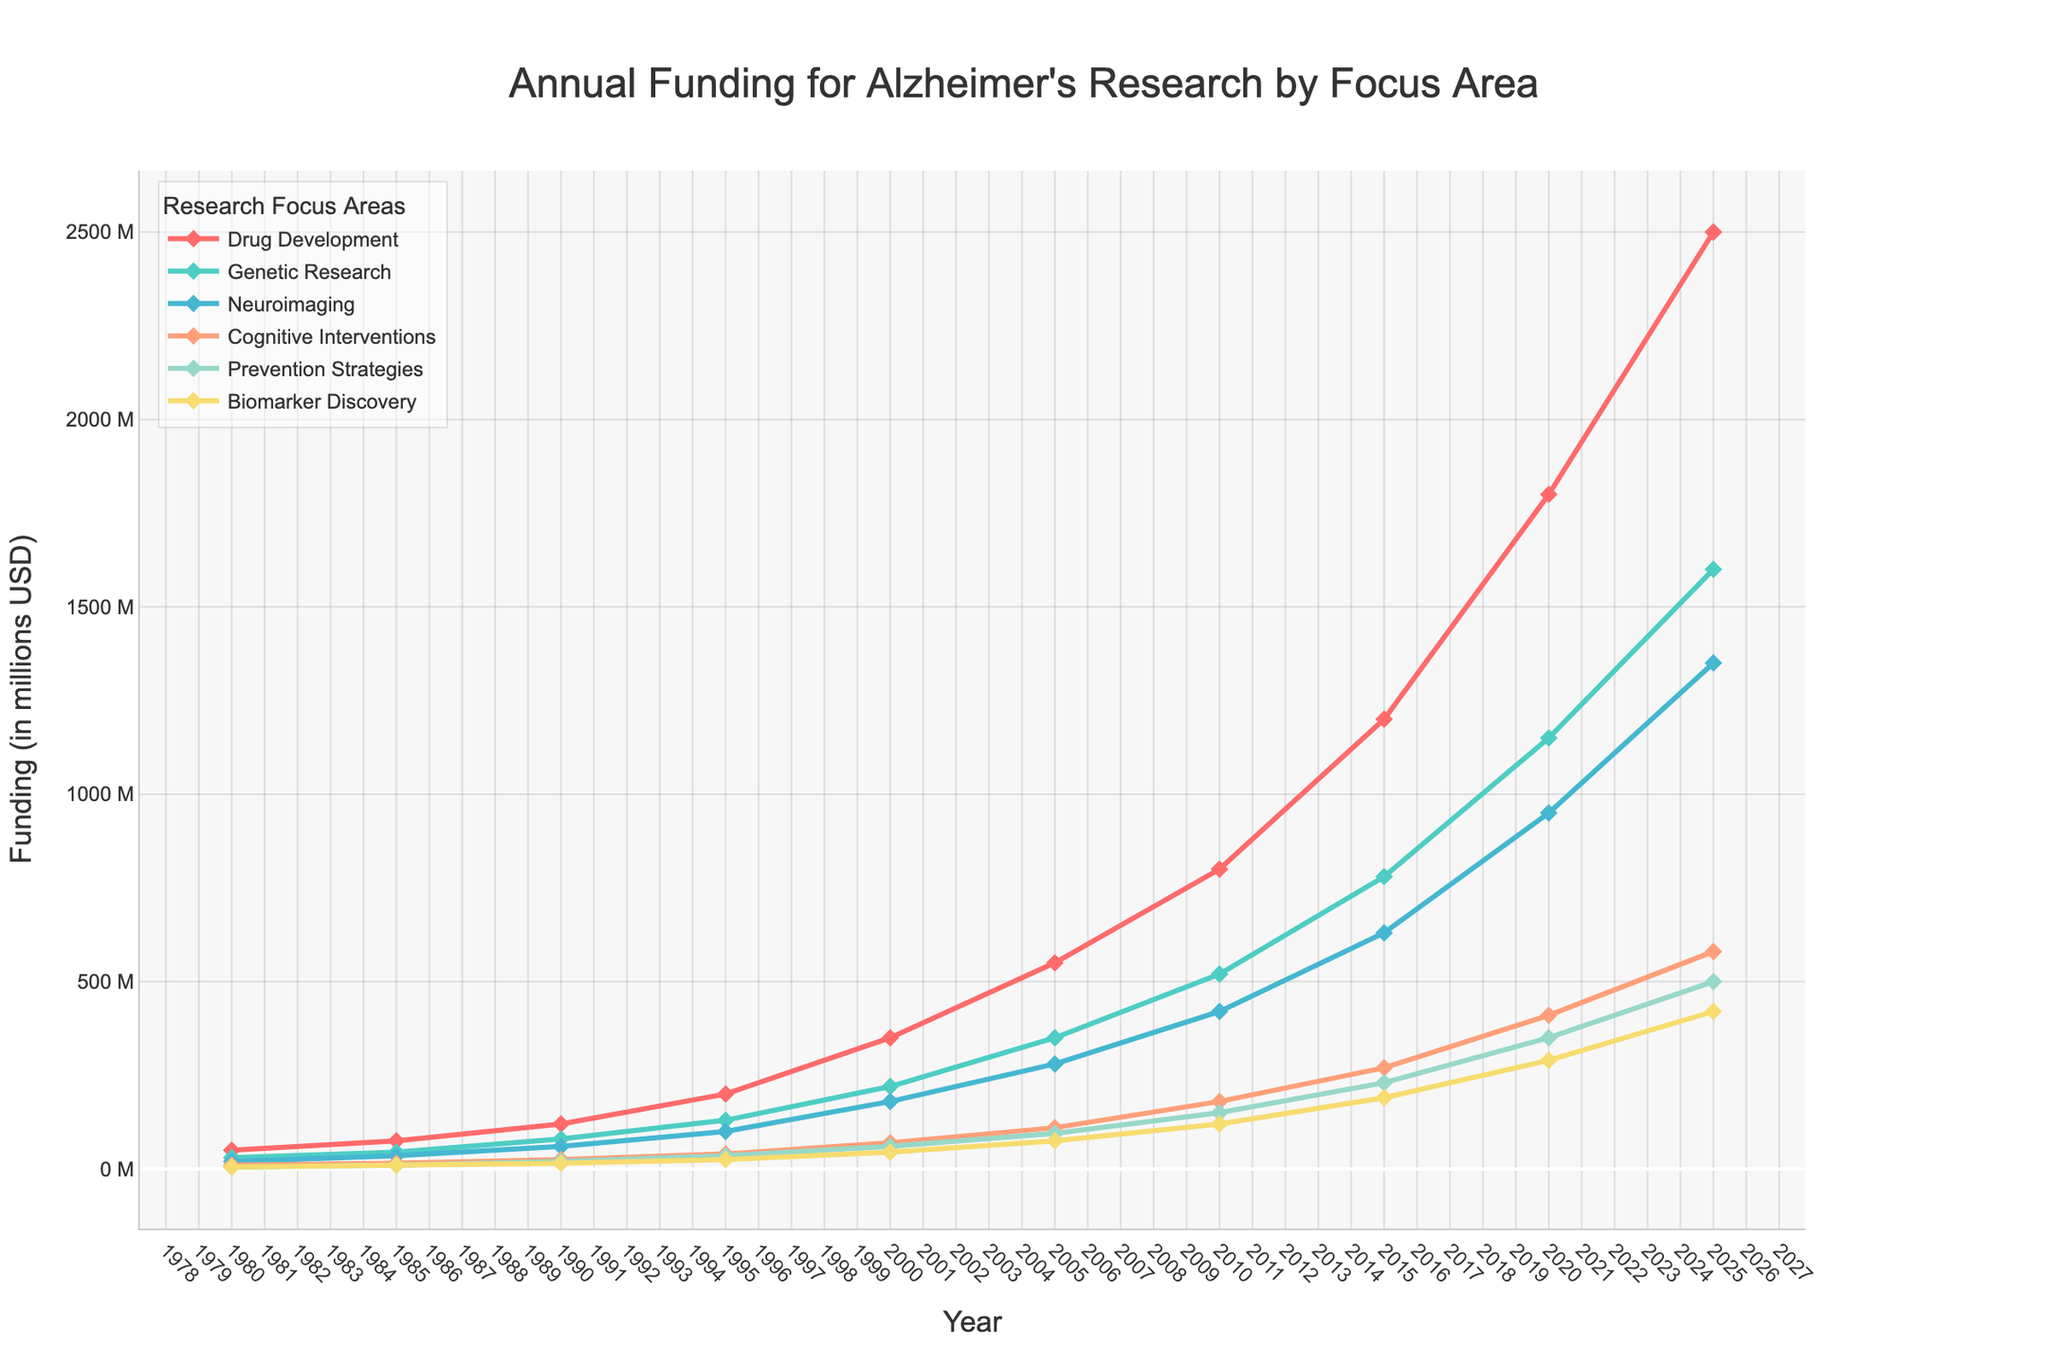What is the total funding for Alzheimer's research across all focus areas in 2025? Add the values for each focus area in 2025: Drug Development (2500) + Genetic Research (1600) + Neuroimaging (1350) + Cognitive Interventions (580) + Prevention Strategies (500) + Biomarker Discovery (420). Thus, the total funding is 2500 + 1600 + 1350 + 580 + 500 + 420 = 6950 million USD.
Answer: 6950 million USD Which research focus area had the highest funding in 2000? Look at the funding values for each research focus area in 2000. Drug Development had 350 million USD, Genetic Research had 220 million USD, Neuroimaging had 180 million USD, Cognitive Interventions had 70 million USD, Prevention Strategies had 60 million USD, and Biomarker Discovery had 45 million USD. Drug Development had the highest funding.
Answer: Drug Development Between what years did the funding for Genetic Research increase by the largest amount? Calculate the increase in funding for Genetic Research for each interval: 1980-1985 (45-30=15), 1985-1990 (80-45=35), 1990-1995 (130-80=50), 1995-2000 (220-130=90), 2000-2005 (350-220=130), 2005-2010 (520-350=170), 2010-2015 (780-520=260), 2015-2020 (1150-780=370), 2020-2025 (1600-1150=450). The largest increase is between 2020-2025.
Answer: 2020-2025 What was the funding difference between Drug Development and Neuroimaging in 2010? Look at the funding for Drug Development (800 million USD) and Neuroimaging (420 million USD) in 2010. The difference is 800 - 420 = 380 million USD.
Answer: 380 million USD Which research focus area had the lowest funding in 1995? Look at the funding values for each research focus area in 1995. Drug Development had 200 million USD, Genetic Research had 130 million USD, Neuroimaging had 100 million USD, Cognitive Interventions had 40 million USD, Prevention Strategies had 35 million USD, and Biomarker Discovery had 25 million USD. Biomarker Discovery had the lowest funding.
Answer: Biomarker Discovery How many focus areas had more than 500 million USD in funding in 2025? Look at the funding values for each focus area in 2025. Drug Development had 2500 million USD, Genetic Research had 1600 million USD, Neuroimaging had 1350 million USD, Cognitive Interventions had 580 million USD, Prevention Strategies had 500 million USD, and Biomarker Discovery had 420 million USD. There are 4 focus areas with more than 500 million USD in funding.
Answer: 4 What is the average annual funding for Cognitive Interventions across all years? Sum the funding values for Cognitive Interventions: 10 + 15 + 25 + 40 + 70 + 110 + 180 + 270 + 410 + 580 = 1710 million USD. There are 10 years, so the average is 1710 / 10 = 171 million USD.
Answer: 171 million USD By how much did funding for Prevention Strategies increase between 1980 and 2025? The funding for Prevention Strategies was 5 million USD in 1980 and 500 million USD in 2025. The increase is 500 - 5 = 495 million USD.
Answer: 495 million USD 